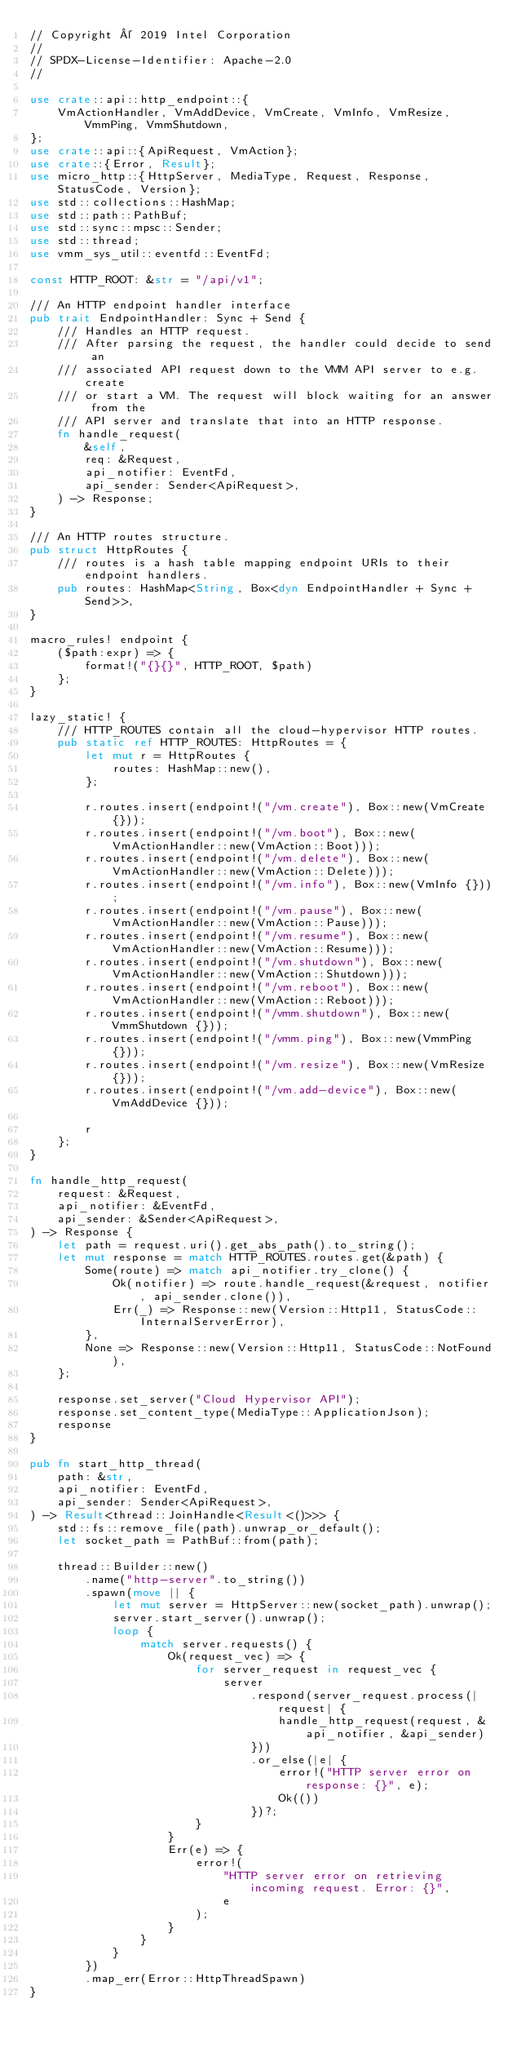<code> <loc_0><loc_0><loc_500><loc_500><_Rust_>// Copyright © 2019 Intel Corporation
//
// SPDX-License-Identifier: Apache-2.0
//

use crate::api::http_endpoint::{
    VmActionHandler, VmAddDevice, VmCreate, VmInfo, VmResize, VmmPing, VmmShutdown,
};
use crate::api::{ApiRequest, VmAction};
use crate::{Error, Result};
use micro_http::{HttpServer, MediaType, Request, Response, StatusCode, Version};
use std::collections::HashMap;
use std::path::PathBuf;
use std::sync::mpsc::Sender;
use std::thread;
use vmm_sys_util::eventfd::EventFd;

const HTTP_ROOT: &str = "/api/v1";

/// An HTTP endpoint handler interface
pub trait EndpointHandler: Sync + Send {
    /// Handles an HTTP request.
    /// After parsing the request, the handler could decide to send an
    /// associated API request down to the VMM API server to e.g. create
    /// or start a VM. The request will block waiting for an answer from the
    /// API server and translate that into an HTTP response.
    fn handle_request(
        &self,
        req: &Request,
        api_notifier: EventFd,
        api_sender: Sender<ApiRequest>,
    ) -> Response;
}

/// An HTTP routes structure.
pub struct HttpRoutes {
    /// routes is a hash table mapping endpoint URIs to their endpoint handlers.
    pub routes: HashMap<String, Box<dyn EndpointHandler + Sync + Send>>,
}

macro_rules! endpoint {
    ($path:expr) => {
        format!("{}{}", HTTP_ROOT, $path)
    };
}

lazy_static! {
    /// HTTP_ROUTES contain all the cloud-hypervisor HTTP routes.
    pub static ref HTTP_ROUTES: HttpRoutes = {
        let mut r = HttpRoutes {
            routes: HashMap::new(),
        };

        r.routes.insert(endpoint!("/vm.create"), Box::new(VmCreate {}));
        r.routes.insert(endpoint!("/vm.boot"), Box::new(VmActionHandler::new(VmAction::Boot)));
        r.routes.insert(endpoint!("/vm.delete"), Box::new(VmActionHandler::new(VmAction::Delete)));
        r.routes.insert(endpoint!("/vm.info"), Box::new(VmInfo {}));
        r.routes.insert(endpoint!("/vm.pause"), Box::new(VmActionHandler::new(VmAction::Pause)));
        r.routes.insert(endpoint!("/vm.resume"), Box::new(VmActionHandler::new(VmAction::Resume)));
        r.routes.insert(endpoint!("/vm.shutdown"), Box::new(VmActionHandler::new(VmAction::Shutdown)));
        r.routes.insert(endpoint!("/vm.reboot"), Box::new(VmActionHandler::new(VmAction::Reboot)));
        r.routes.insert(endpoint!("/vmm.shutdown"), Box::new(VmmShutdown {}));
        r.routes.insert(endpoint!("/vmm.ping"), Box::new(VmmPing {}));
        r.routes.insert(endpoint!("/vm.resize"), Box::new(VmResize {}));
        r.routes.insert(endpoint!("/vm.add-device"), Box::new(VmAddDevice {}));

        r
    };
}

fn handle_http_request(
    request: &Request,
    api_notifier: &EventFd,
    api_sender: &Sender<ApiRequest>,
) -> Response {
    let path = request.uri().get_abs_path().to_string();
    let mut response = match HTTP_ROUTES.routes.get(&path) {
        Some(route) => match api_notifier.try_clone() {
            Ok(notifier) => route.handle_request(&request, notifier, api_sender.clone()),
            Err(_) => Response::new(Version::Http11, StatusCode::InternalServerError),
        },
        None => Response::new(Version::Http11, StatusCode::NotFound),
    };

    response.set_server("Cloud Hypervisor API");
    response.set_content_type(MediaType::ApplicationJson);
    response
}

pub fn start_http_thread(
    path: &str,
    api_notifier: EventFd,
    api_sender: Sender<ApiRequest>,
) -> Result<thread::JoinHandle<Result<()>>> {
    std::fs::remove_file(path).unwrap_or_default();
    let socket_path = PathBuf::from(path);

    thread::Builder::new()
        .name("http-server".to_string())
        .spawn(move || {
            let mut server = HttpServer::new(socket_path).unwrap();
            server.start_server().unwrap();
            loop {
                match server.requests() {
                    Ok(request_vec) => {
                        for server_request in request_vec {
                            server
                                .respond(server_request.process(|request| {
                                    handle_http_request(request, &api_notifier, &api_sender)
                                }))
                                .or_else(|e| {
                                    error!("HTTP server error on response: {}", e);
                                    Ok(())
                                })?;
                        }
                    }
                    Err(e) => {
                        error!(
                            "HTTP server error on retrieving incoming request. Error: {}",
                            e
                        );
                    }
                }
            }
        })
        .map_err(Error::HttpThreadSpawn)
}
</code> 